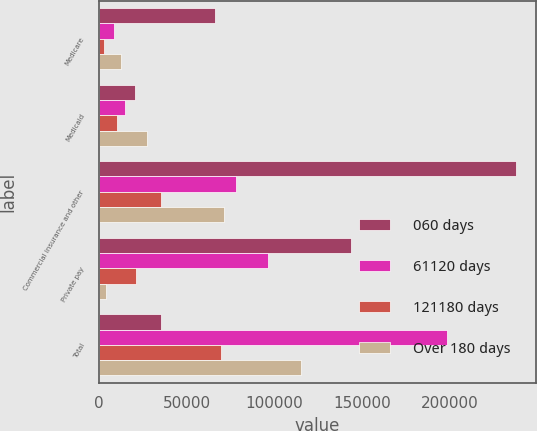<chart> <loc_0><loc_0><loc_500><loc_500><stacked_bar_chart><ecel><fcel>Medicare<fcel>Medicaid<fcel>Commercial insurance and other<fcel>Private pay<fcel>Total<nl><fcel>060 days<fcel>66125<fcel>20710<fcel>237587<fcel>143683<fcel>35671<nl><fcel>61120 days<fcel>8885<fcel>15095<fcel>78048<fcel>96294<fcel>198322<nl><fcel>121180 days<fcel>2983<fcel>10309<fcel>35671<fcel>20983<fcel>69946<nl><fcel>Over 180 days<fcel>12500<fcel>27422<fcel>71191<fcel>4354<fcel>115467<nl></chart> 